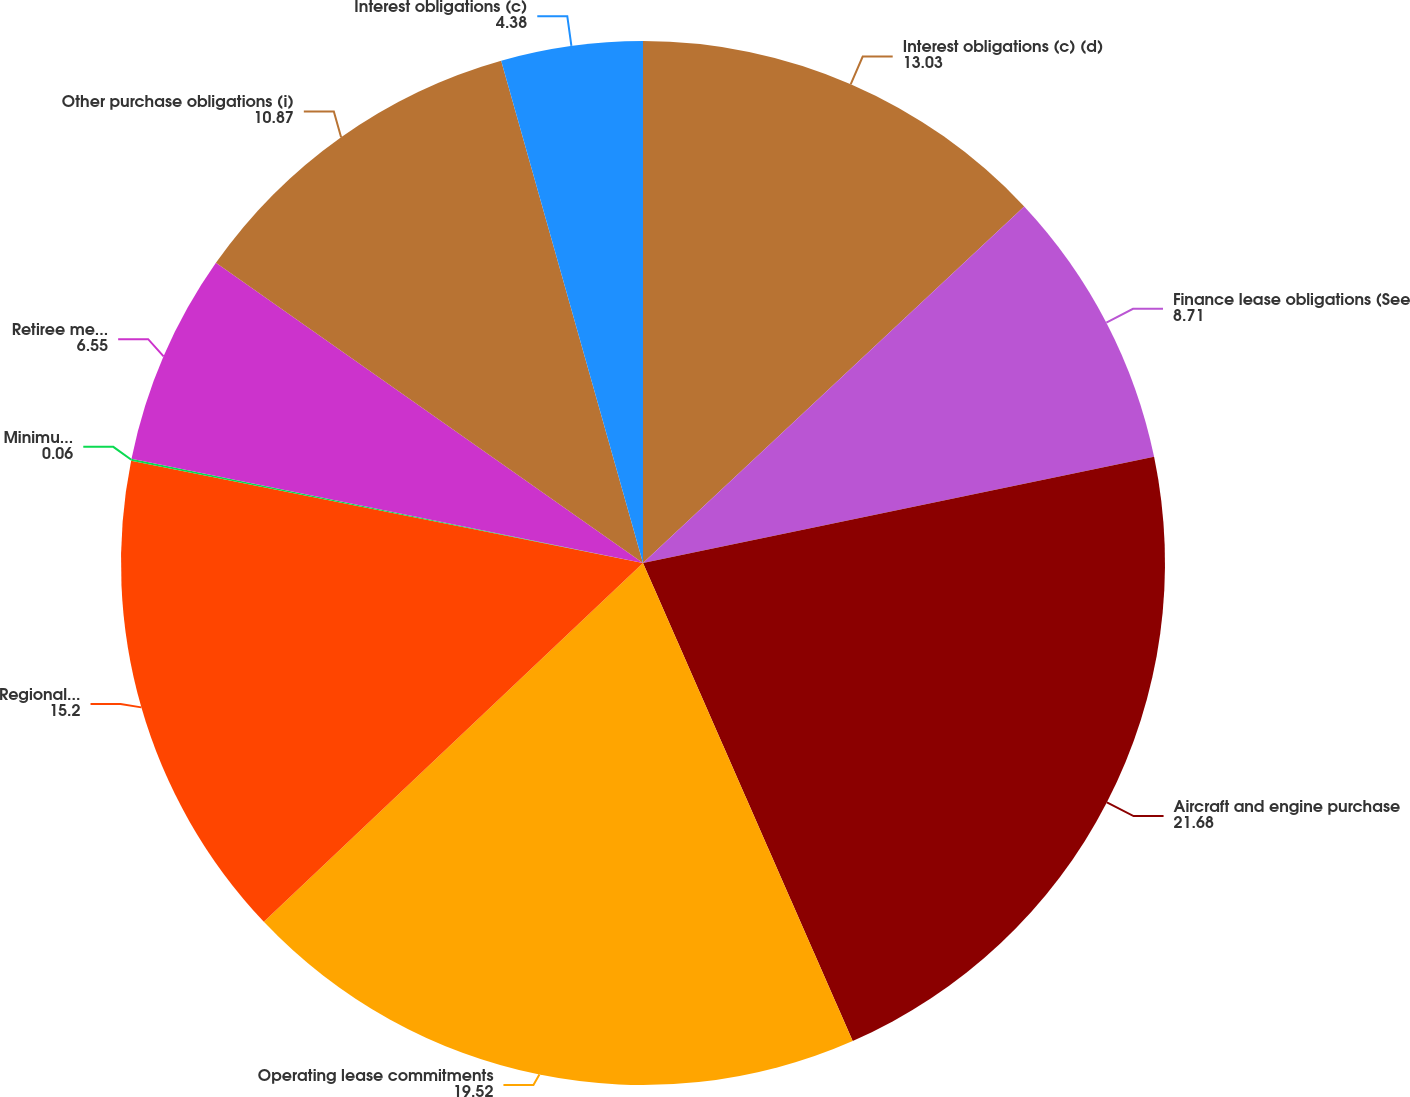<chart> <loc_0><loc_0><loc_500><loc_500><pie_chart><fcel>Interest obligations (c) (d)<fcel>Finance lease obligations (See<fcel>Aircraft and engine purchase<fcel>Operating lease commitments<fcel>Regional capacity purchase<fcel>Minimum pension obligations<fcel>Retiree medical and other<fcel>Other purchase obligations (i)<fcel>Interest obligations (c)<nl><fcel>13.03%<fcel>8.71%<fcel>21.68%<fcel>19.52%<fcel>15.2%<fcel>0.06%<fcel>6.55%<fcel>10.87%<fcel>4.38%<nl></chart> 